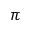<formula> <loc_0><loc_0><loc_500><loc_500>\pi</formula> 